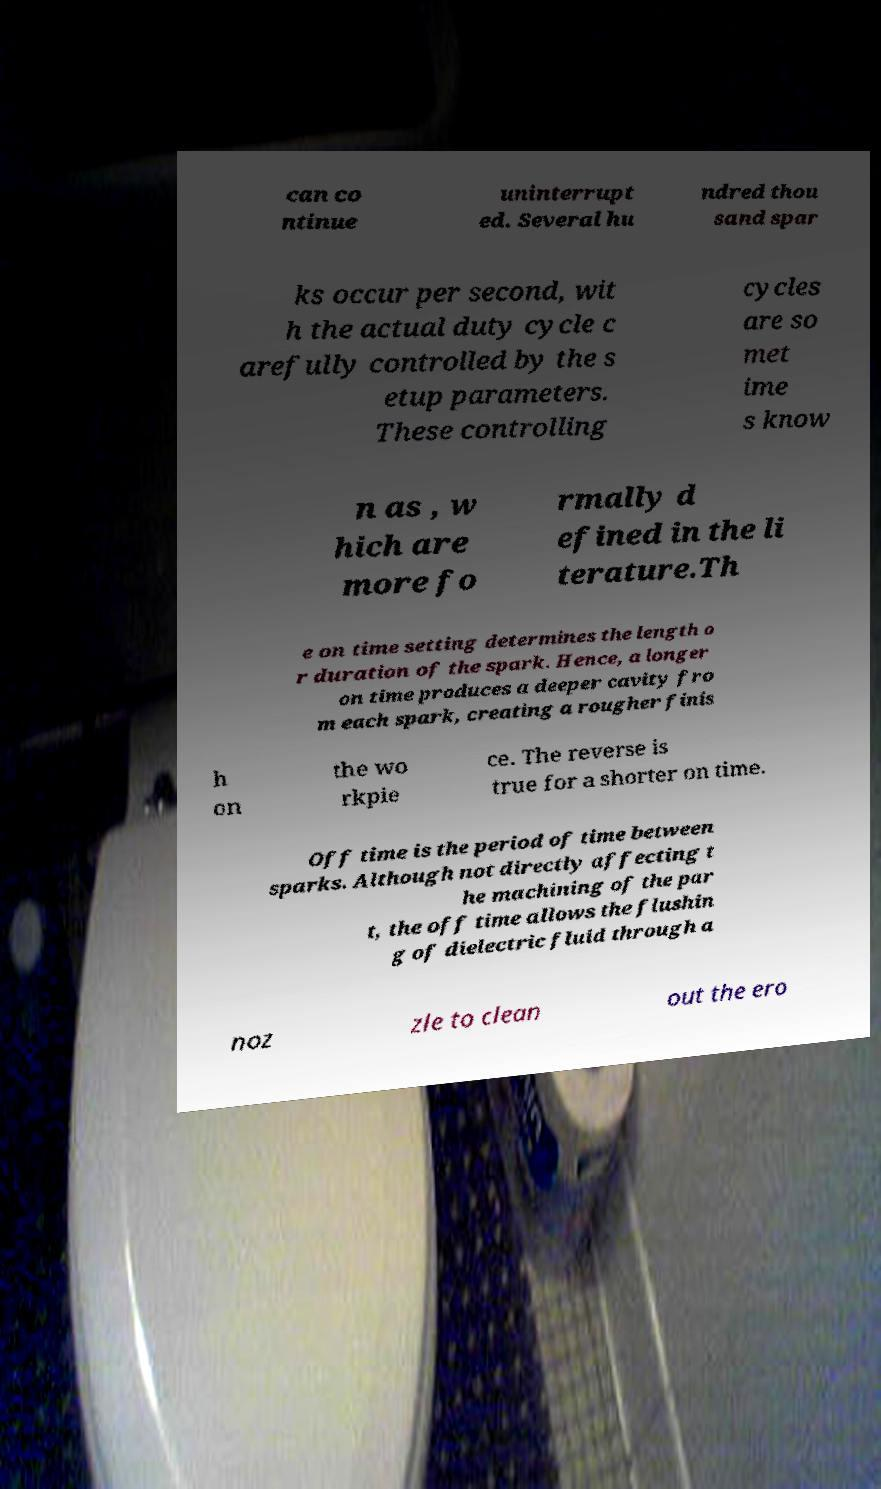Please identify and transcribe the text found in this image. can co ntinue uninterrupt ed. Several hu ndred thou sand spar ks occur per second, wit h the actual duty cycle c arefully controlled by the s etup parameters. These controlling cycles are so met ime s know n as , w hich are more fo rmally d efined in the li terature.Th e on time setting determines the length o r duration of the spark. Hence, a longer on time produces a deeper cavity fro m each spark, creating a rougher finis h on the wo rkpie ce. The reverse is true for a shorter on time. Off time is the period of time between sparks. Although not directly affecting t he machining of the par t, the off time allows the flushin g of dielectric fluid through a noz zle to clean out the ero 